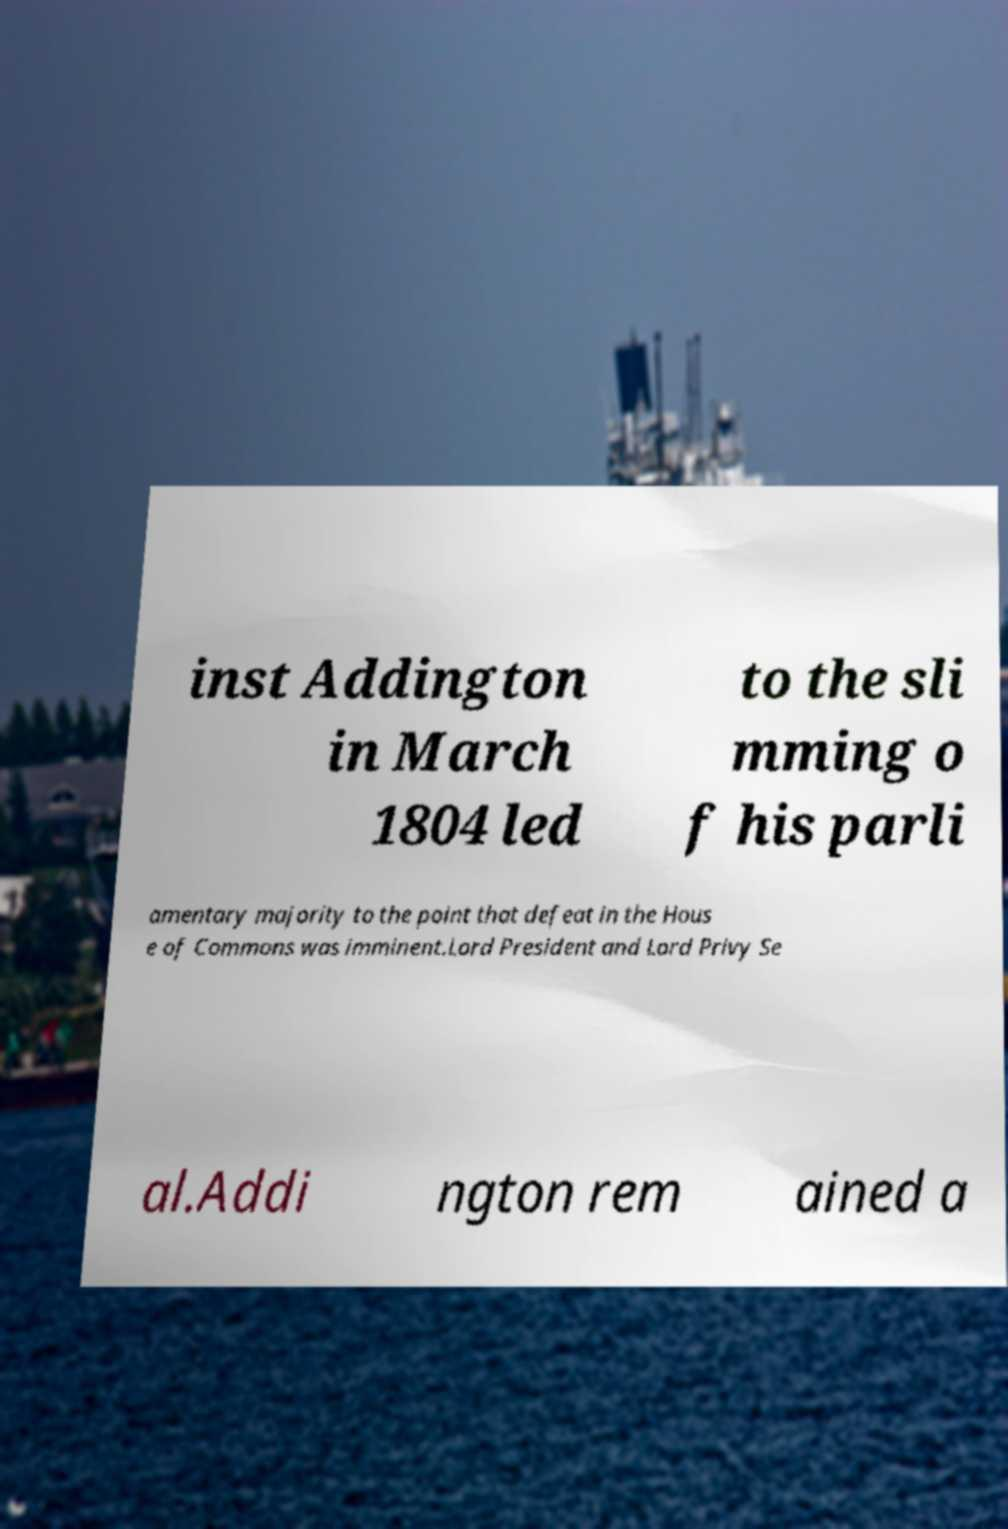Can you accurately transcribe the text from the provided image for me? inst Addington in March 1804 led to the sli mming o f his parli amentary majority to the point that defeat in the Hous e of Commons was imminent.Lord President and Lord Privy Se al.Addi ngton rem ained a 